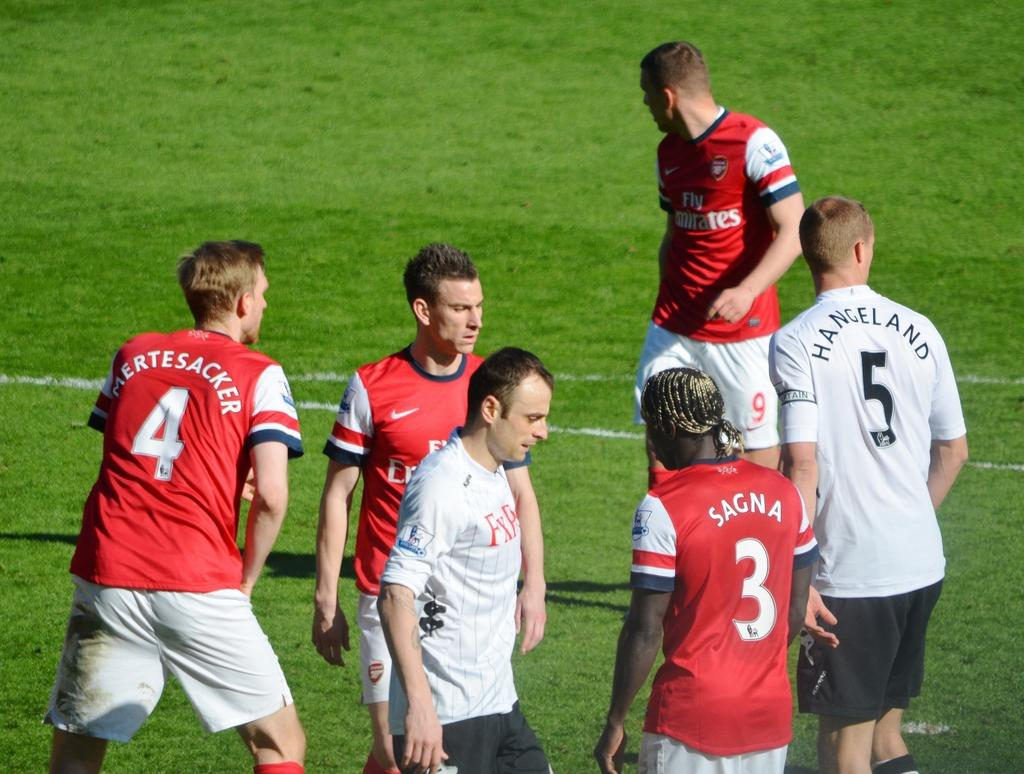What is the main subject of the image? The main subject of the image is a group of people. What can be observed about the clothing of some people in the group? Some people in the group are wearing red color t-shirts. What type of surface are the people standing on? The people are standing on the grass. What type of toy can be seen in the hands of the people in the image? There is no toy visible in the hands of the people in the image. 